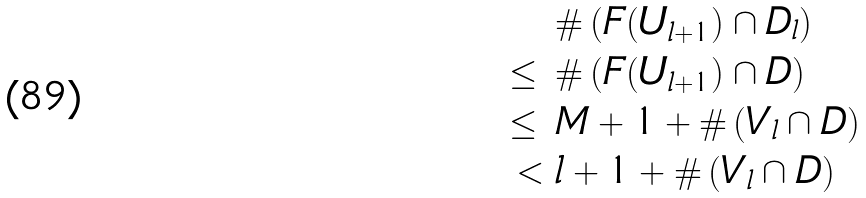Convert formula to latex. <formula><loc_0><loc_0><loc_500><loc_500>& \# \left ( F ( U _ { l + 1 } ) \cap D _ { l } \right ) \\ \leq \ & \# \left ( F ( U _ { l + 1 } ) \cap D \right ) \\ \leq \ & M + 1 + \# \left ( V _ { l } \cap D \right ) \\ < \ & l + 1 + \# \left ( V _ { l } \cap D \right ) \\</formula> 